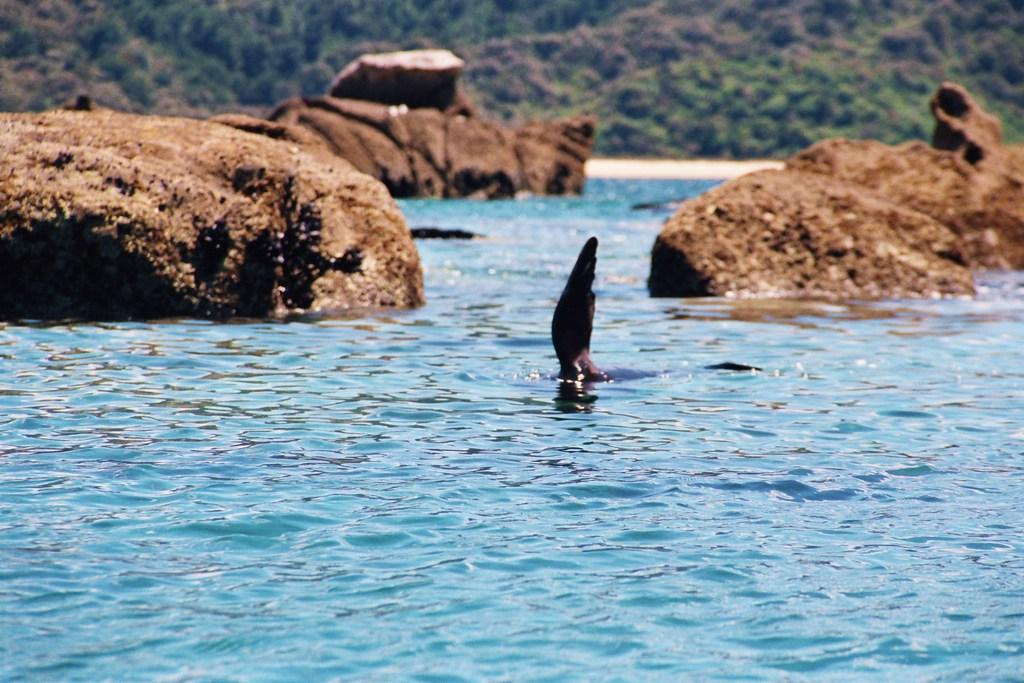What is visible in the foreground of the image? There is a fin of an animal in the water in the foreground. What can be seen in the background of the image? There are rocks, trees, and sand in the background. What type of committee can be seen meeting on the sand in the image? There is no committee present in the image; it features a fin of an animal in the water and natural elements in the background. 